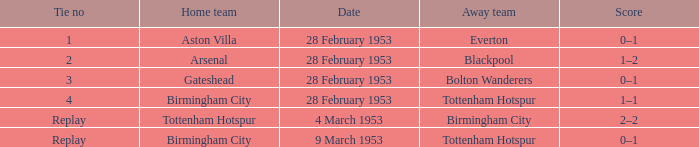Which Score has a Home team of aston villa? 0–1. Parse the table in full. {'header': ['Tie no', 'Home team', 'Date', 'Away team', 'Score'], 'rows': [['1', 'Aston Villa', '28 February 1953', 'Everton', '0–1'], ['2', 'Arsenal', '28 February 1953', 'Blackpool', '1–2'], ['3', 'Gateshead', '28 February 1953', 'Bolton Wanderers', '0–1'], ['4', 'Birmingham City', '28 February 1953', 'Tottenham Hotspur', '1–1'], ['Replay', 'Tottenham Hotspur', '4 March 1953', 'Birmingham City', '2–2'], ['Replay', 'Birmingham City', '9 March 1953', 'Tottenham Hotspur', '0–1']]} 